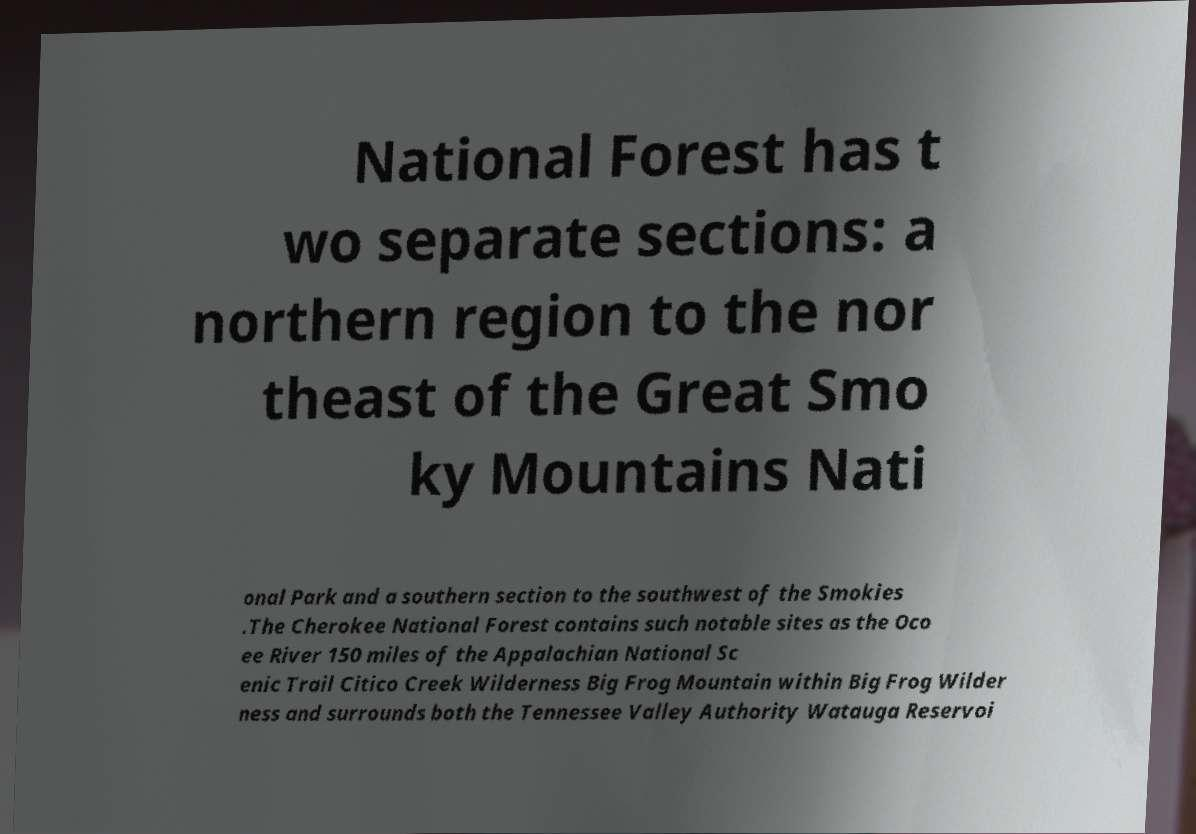Can you accurately transcribe the text from the provided image for me? National Forest has t wo separate sections: a northern region to the nor theast of the Great Smo ky Mountains Nati onal Park and a southern section to the southwest of the Smokies .The Cherokee National Forest contains such notable sites as the Oco ee River 150 miles of the Appalachian National Sc enic Trail Citico Creek Wilderness Big Frog Mountain within Big Frog Wilder ness and surrounds both the Tennessee Valley Authority Watauga Reservoi 